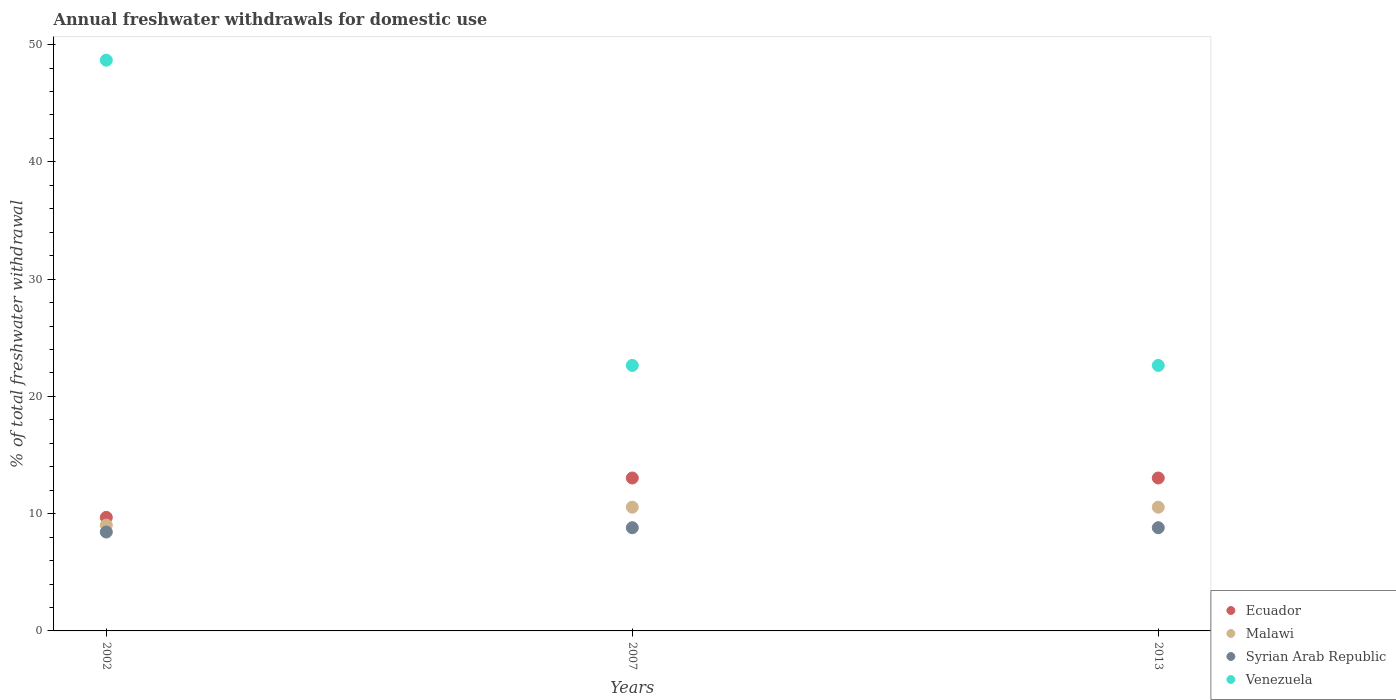How many different coloured dotlines are there?
Your response must be concise. 4. Is the number of dotlines equal to the number of legend labels?
Provide a short and direct response. Yes. What is the total annual withdrawals from freshwater in Syrian Arab Republic in 2002?
Provide a succinct answer. 8.44. Across all years, what is the maximum total annual withdrawals from freshwater in Syrian Arab Republic?
Your response must be concise. 8.8. Across all years, what is the minimum total annual withdrawals from freshwater in Venezuela?
Ensure brevity in your answer.  22.64. In which year was the total annual withdrawals from freshwater in Malawi minimum?
Ensure brevity in your answer.  2002. What is the total total annual withdrawals from freshwater in Syrian Arab Republic in the graph?
Provide a succinct answer. 26.04. What is the difference between the total annual withdrawals from freshwater in Ecuador in 2007 and that in 2013?
Make the answer very short. 0. What is the difference between the total annual withdrawals from freshwater in Venezuela in 2002 and the total annual withdrawals from freshwater in Malawi in 2013?
Offer a very short reply. 38.12. What is the average total annual withdrawals from freshwater in Syrian Arab Republic per year?
Your answer should be compact. 8.68. In the year 2002, what is the difference between the total annual withdrawals from freshwater in Syrian Arab Republic and total annual withdrawals from freshwater in Ecuador?
Offer a terse response. -1.25. In how many years, is the total annual withdrawals from freshwater in Venezuela greater than 28 %?
Provide a short and direct response. 1. What is the ratio of the total annual withdrawals from freshwater in Ecuador in 2002 to that in 2007?
Provide a succinct answer. 0.74. Is the total annual withdrawals from freshwater in Malawi in 2002 less than that in 2013?
Give a very brief answer. Yes. What is the difference between the highest and the second highest total annual withdrawals from freshwater in Venezuela?
Offer a very short reply. 26.03. What is the difference between the highest and the lowest total annual withdrawals from freshwater in Venezuela?
Give a very brief answer. 26.03. Is the sum of the total annual withdrawals from freshwater in Ecuador in 2002 and 2007 greater than the maximum total annual withdrawals from freshwater in Venezuela across all years?
Ensure brevity in your answer.  No. Does the total annual withdrawals from freshwater in Venezuela monotonically increase over the years?
Provide a succinct answer. No. How many years are there in the graph?
Your answer should be very brief. 3. Does the graph contain grids?
Give a very brief answer. No. Where does the legend appear in the graph?
Offer a terse response. Bottom right. How many legend labels are there?
Ensure brevity in your answer.  4. How are the legend labels stacked?
Your answer should be compact. Vertical. What is the title of the graph?
Keep it short and to the point. Annual freshwater withdrawals for domestic use. What is the label or title of the Y-axis?
Offer a terse response. % of total freshwater withdrawal. What is the % of total freshwater withdrawal of Ecuador in 2002?
Offer a terse response. 9.68. What is the % of total freshwater withdrawal of Malawi in 2002?
Your answer should be very brief. 9.03. What is the % of total freshwater withdrawal in Syrian Arab Republic in 2002?
Offer a very short reply. 8.44. What is the % of total freshwater withdrawal of Venezuela in 2002?
Make the answer very short. 48.67. What is the % of total freshwater withdrawal of Ecuador in 2007?
Give a very brief answer. 13.04. What is the % of total freshwater withdrawal in Malawi in 2007?
Your response must be concise. 10.55. What is the % of total freshwater withdrawal of Syrian Arab Republic in 2007?
Provide a succinct answer. 8.8. What is the % of total freshwater withdrawal of Venezuela in 2007?
Make the answer very short. 22.64. What is the % of total freshwater withdrawal of Ecuador in 2013?
Ensure brevity in your answer.  13.04. What is the % of total freshwater withdrawal of Malawi in 2013?
Give a very brief answer. 10.55. What is the % of total freshwater withdrawal of Syrian Arab Republic in 2013?
Keep it short and to the point. 8.8. What is the % of total freshwater withdrawal of Venezuela in 2013?
Your response must be concise. 22.64. Across all years, what is the maximum % of total freshwater withdrawal of Ecuador?
Offer a terse response. 13.04. Across all years, what is the maximum % of total freshwater withdrawal of Malawi?
Provide a succinct answer. 10.55. Across all years, what is the maximum % of total freshwater withdrawal in Syrian Arab Republic?
Ensure brevity in your answer.  8.8. Across all years, what is the maximum % of total freshwater withdrawal of Venezuela?
Your response must be concise. 48.67. Across all years, what is the minimum % of total freshwater withdrawal of Ecuador?
Offer a terse response. 9.68. Across all years, what is the minimum % of total freshwater withdrawal of Malawi?
Provide a succinct answer. 9.03. Across all years, what is the minimum % of total freshwater withdrawal in Syrian Arab Republic?
Keep it short and to the point. 8.44. Across all years, what is the minimum % of total freshwater withdrawal in Venezuela?
Offer a very short reply. 22.64. What is the total % of total freshwater withdrawal in Ecuador in the graph?
Give a very brief answer. 35.76. What is the total % of total freshwater withdrawal in Malawi in the graph?
Keep it short and to the point. 30.13. What is the total % of total freshwater withdrawal in Syrian Arab Republic in the graph?
Offer a very short reply. 26.04. What is the total % of total freshwater withdrawal in Venezuela in the graph?
Your answer should be compact. 93.95. What is the difference between the % of total freshwater withdrawal in Ecuador in 2002 and that in 2007?
Keep it short and to the point. -3.36. What is the difference between the % of total freshwater withdrawal in Malawi in 2002 and that in 2007?
Offer a very short reply. -1.52. What is the difference between the % of total freshwater withdrawal in Syrian Arab Republic in 2002 and that in 2007?
Your response must be concise. -0.37. What is the difference between the % of total freshwater withdrawal in Venezuela in 2002 and that in 2007?
Offer a terse response. 26.03. What is the difference between the % of total freshwater withdrawal in Ecuador in 2002 and that in 2013?
Keep it short and to the point. -3.36. What is the difference between the % of total freshwater withdrawal in Malawi in 2002 and that in 2013?
Provide a short and direct response. -1.52. What is the difference between the % of total freshwater withdrawal of Syrian Arab Republic in 2002 and that in 2013?
Give a very brief answer. -0.37. What is the difference between the % of total freshwater withdrawal in Venezuela in 2002 and that in 2013?
Make the answer very short. 26.03. What is the difference between the % of total freshwater withdrawal of Malawi in 2007 and that in 2013?
Your response must be concise. 0. What is the difference between the % of total freshwater withdrawal of Venezuela in 2007 and that in 2013?
Offer a terse response. 0. What is the difference between the % of total freshwater withdrawal of Ecuador in 2002 and the % of total freshwater withdrawal of Malawi in 2007?
Keep it short and to the point. -0.87. What is the difference between the % of total freshwater withdrawal in Ecuador in 2002 and the % of total freshwater withdrawal in Syrian Arab Republic in 2007?
Your answer should be compact. 0.88. What is the difference between the % of total freshwater withdrawal in Ecuador in 2002 and the % of total freshwater withdrawal in Venezuela in 2007?
Offer a terse response. -12.96. What is the difference between the % of total freshwater withdrawal in Malawi in 2002 and the % of total freshwater withdrawal in Syrian Arab Republic in 2007?
Offer a terse response. 0.23. What is the difference between the % of total freshwater withdrawal in Malawi in 2002 and the % of total freshwater withdrawal in Venezuela in 2007?
Provide a succinct answer. -13.61. What is the difference between the % of total freshwater withdrawal of Syrian Arab Republic in 2002 and the % of total freshwater withdrawal of Venezuela in 2007?
Keep it short and to the point. -14.21. What is the difference between the % of total freshwater withdrawal of Ecuador in 2002 and the % of total freshwater withdrawal of Malawi in 2013?
Your response must be concise. -0.87. What is the difference between the % of total freshwater withdrawal of Ecuador in 2002 and the % of total freshwater withdrawal of Syrian Arab Republic in 2013?
Your response must be concise. 0.88. What is the difference between the % of total freshwater withdrawal in Ecuador in 2002 and the % of total freshwater withdrawal in Venezuela in 2013?
Your answer should be very brief. -12.96. What is the difference between the % of total freshwater withdrawal in Malawi in 2002 and the % of total freshwater withdrawal in Syrian Arab Republic in 2013?
Ensure brevity in your answer.  0.23. What is the difference between the % of total freshwater withdrawal in Malawi in 2002 and the % of total freshwater withdrawal in Venezuela in 2013?
Give a very brief answer. -13.61. What is the difference between the % of total freshwater withdrawal in Syrian Arab Republic in 2002 and the % of total freshwater withdrawal in Venezuela in 2013?
Keep it short and to the point. -14.21. What is the difference between the % of total freshwater withdrawal in Ecuador in 2007 and the % of total freshwater withdrawal in Malawi in 2013?
Offer a terse response. 2.49. What is the difference between the % of total freshwater withdrawal in Ecuador in 2007 and the % of total freshwater withdrawal in Syrian Arab Republic in 2013?
Keep it short and to the point. 4.24. What is the difference between the % of total freshwater withdrawal in Ecuador in 2007 and the % of total freshwater withdrawal in Venezuela in 2013?
Ensure brevity in your answer.  -9.6. What is the difference between the % of total freshwater withdrawal in Malawi in 2007 and the % of total freshwater withdrawal in Syrian Arab Republic in 2013?
Keep it short and to the point. 1.75. What is the difference between the % of total freshwater withdrawal in Malawi in 2007 and the % of total freshwater withdrawal in Venezuela in 2013?
Provide a short and direct response. -12.09. What is the difference between the % of total freshwater withdrawal of Syrian Arab Republic in 2007 and the % of total freshwater withdrawal of Venezuela in 2013?
Ensure brevity in your answer.  -13.84. What is the average % of total freshwater withdrawal of Ecuador per year?
Your answer should be compact. 11.92. What is the average % of total freshwater withdrawal in Malawi per year?
Give a very brief answer. 10.04. What is the average % of total freshwater withdrawal in Syrian Arab Republic per year?
Your answer should be very brief. 8.68. What is the average % of total freshwater withdrawal of Venezuela per year?
Your answer should be very brief. 31.32. In the year 2002, what is the difference between the % of total freshwater withdrawal in Ecuador and % of total freshwater withdrawal in Malawi?
Give a very brief answer. 0.66. In the year 2002, what is the difference between the % of total freshwater withdrawal in Ecuador and % of total freshwater withdrawal in Syrian Arab Republic?
Provide a short and direct response. 1.25. In the year 2002, what is the difference between the % of total freshwater withdrawal of Ecuador and % of total freshwater withdrawal of Venezuela?
Your response must be concise. -38.99. In the year 2002, what is the difference between the % of total freshwater withdrawal of Malawi and % of total freshwater withdrawal of Syrian Arab Republic?
Your response must be concise. 0.59. In the year 2002, what is the difference between the % of total freshwater withdrawal of Malawi and % of total freshwater withdrawal of Venezuela?
Offer a very short reply. -39.64. In the year 2002, what is the difference between the % of total freshwater withdrawal of Syrian Arab Republic and % of total freshwater withdrawal of Venezuela?
Offer a very short reply. -40.23. In the year 2007, what is the difference between the % of total freshwater withdrawal of Ecuador and % of total freshwater withdrawal of Malawi?
Ensure brevity in your answer.  2.49. In the year 2007, what is the difference between the % of total freshwater withdrawal of Ecuador and % of total freshwater withdrawal of Syrian Arab Republic?
Make the answer very short. 4.24. In the year 2007, what is the difference between the % of total freshwater withdrawal in Malawi and % of total freshwater withdrawal in Syrian Arab Republic?
Provide a succinct answer. 1.75. In the year 2007, what is the difference between the % of total freshwater withdrawal of Malawi and % of total freshwater withdrawal of Venezuela?
Keep it short and to the point. -12.09. In the year 2007, what is the difference between the % of total freshwater withdrawal of Syrian Arab Republic and % of total freshwater withdrawal of Venezuela?
Your response must be concise. -13.84. In the year 2013, what is the difference between the % of total freshwater withdrawal in Ecuador and % of total freshwater withdrawal in Malawi?
Offer a very short reply. 2.49. In the year 2013, what is the difference between the % of total freshwater withdrawal in Ecuador and % of total freshwater withdrawal in Syrian Arab Republic?
Provide a succinct answer. 4.24. In the year 2013, what is the difference between the % of total freshwater withdrawal in Malawi and % of total freshwater withdrawal in Syrian Arab Republic?
Offer a very short reply. 1.75. In the year 2013, what is the difference between the % of total freshwater withdrawal in Malawi and % of total freshwater withdrawal in Venezuela?
Give a very brief answer. -12.09. In the year 2013, what is the difference between the % of total freshwater withdrawal in Syrian Arab Republic and % of total freshwater withdrawal in Venezuela?
Your answer should be very brief. -13.84. What is the ratio of the % of total freshwater withdrawal of Ecuador in 2002 to that in 2007?
Offer a terse response. 0.74. What is the ratio of the % of total freshwater withdrawal in Malawi in 2002 to that in 2007?
Your response must be concise. 0.86. What is the ratio of the % of total freshwater withdrawal of Syrian Arab Republic in 2002 to that in 2007?
Keep it short and to the point. 0.96. What is the ratio of the % of total freshwater withdrawal in Venezuela in 2002 to that in 2007?
Your answer should be very brief. 2.15. What is the ratio of the % of total freshwater withdrawal of Ecuador in 2002 to that in 2013?
Ensure brevity in your answer.  0.74. What is the ratio of the % of total freshwater withdrawal of Malawi in 2002 to that in 2013?
Provide a short and direct response. 0.86. What is the ratio of the % of total freshwater withdrawal in Syrian Arab Republic in 2002 to that in 2013?
Offer a terse response. 0.96. What is the ratio of the % of total freshwater withdrawal of Venezuela in 2002 to that in 2013?
Offer a terse response. 2.15. What is the ratio of the % of total freshwater withdrawal in Ecuador in 2007 to that in 2013?
Make the answer very short. 1. What is the ratio of the % of total freshwater withdrawal in Syrian Arab Republic in 2007 to that in 2013?
Keep it short and to the point. 1. What is the ratio of the % of total freshwater withdrawal of Venezuela in 2007 to that in 2013?
Give a very brief answer. 1. What is the difference between the highest and the second highest % of total freshwater withdrawal of Venezuela?
Ensure brevity in your answer.  26.03. What is the difference between the highest and the lowest % of total freshwater withdrawal in Ecuador?
Provide a short and direct response. 3.36. What is the difference between the highest and the lowest % of total freshwater withdrawal of Malawi?
Ensure brevity in your answer.  1.52. What is the difference between the highest and the lowest % of total freshwater withdrawal of Syrian Arab Republic?
Your response must be concise. 0.37. What is the difference between the highest and the lowest % of total freshwater withdrawal of Venezuela?
Your answer should be very brief. 26.03. 